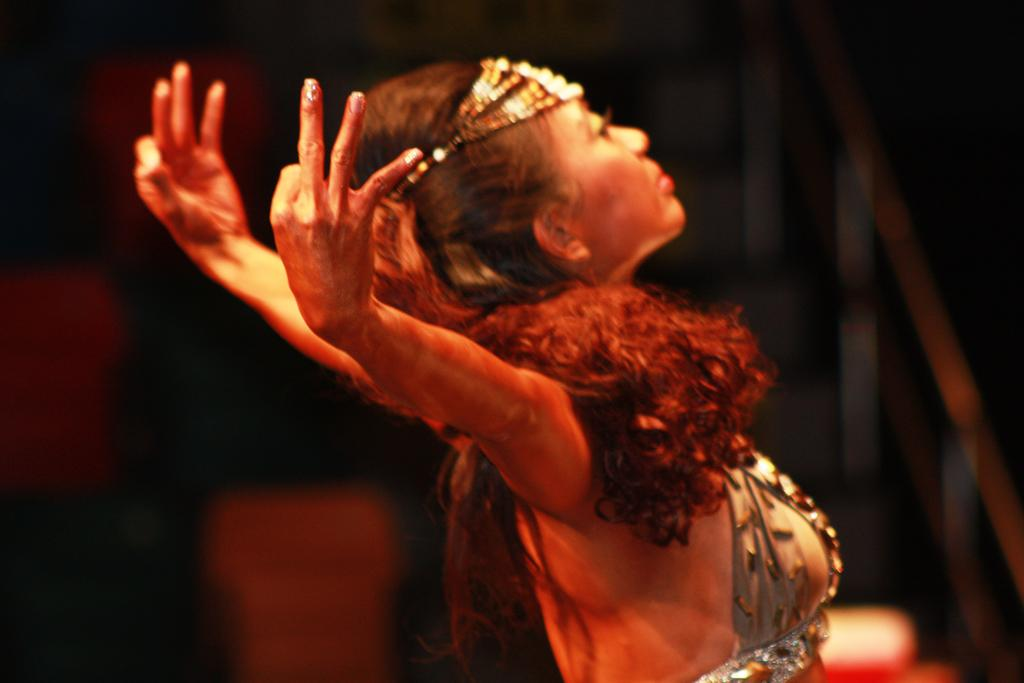Who is the main subject in the image? There is a woman in the image. What is the woman wearing? The woman is wearing clothes. What is the woman doing in the image? The woman appears to be dancing. Can you describe the background of the image? The background of the image is blurred. Is the woman in danger of sinking into quicksand in the image? There is no quicksand present in the image, so the woman is not in danger of sinking into it. 